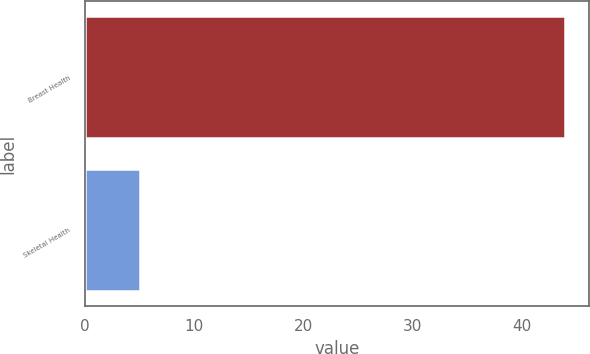Convert chart to OTSL. <chart><loc_0><loc_0><loc_500><loc_500><bar_chart><fcel>Breast Health<fcel>Skeletal Health<nl><fcel>44<fcel>5<nl></chart> 